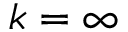Convert formula to latex. <formula><loc_0><loc_0><loc_500><loc_500>k = \infty</formula> 